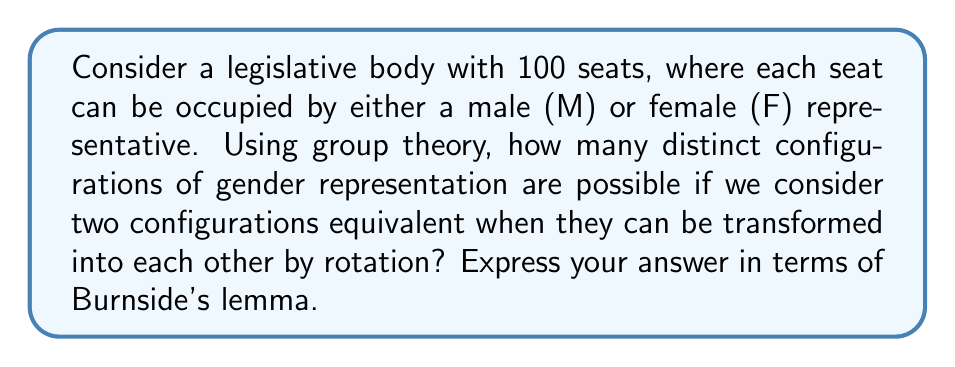Could you help me with this problem? To solve this problem, we'll use Burnside's lemma from group theory. This lemma is particularly useful for counting orbits under a group action, which in this case represents the distinct configurations of gender representation under rotation.

1) First, let's define our group and set:
   - G is the cyclic group of rotations C₁₀₀
   - X is the set of all possible gender configurations (2¹⁰⁰ in total)

2) Burnside's lemma states that the number of orbits |X/G| is:

   $$ |X/G| = \frac{1}{|G|} \sum_{g \in G} |X^g| $$

   where |X^g| is the number of elements in X fixed by g.

3) For each divisor d of 100, there are φ(d) elements of order 100/d in C₁₀₀, where φ is Euler's totient function.

4) An element g of order 100/d fixes a configuration if and only if that configuration consists of d repeated blocks, each of length 100/d.

5) The number of configurations fixed by an element of order 100/d is 2^d, as we have 2 choices (M or F) for each of the d positions in the repeated block.

6) Therefore, we can rewrite Burnside's lemma as:

   $$ |X/G| = \frac{1}{100} \sum_{d|100} \phi(\frac{100}{d}) 2^d $$

This sum gives us the number of distinct configurations under rotation.
Answer: The number of distinct configurations of gender representation under rotation is:

$$ \frac{1}{100} \sum_{d|100} \phi(\frac{100}{d}) 2^d $$

where the sum is taken over all divisors d of 100, and φ is Euler's totient function. 